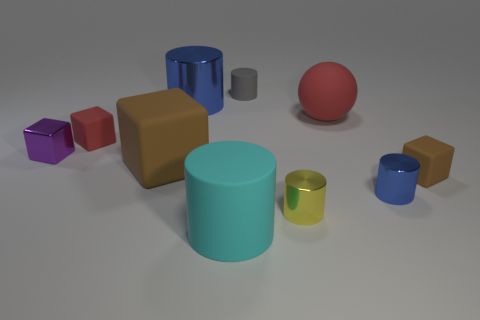What material do the objects look like they are made of? The objects in the image seem to have a matte or slightly shiny finish, suggesting they might be made from materials like plastic or painted wood. 